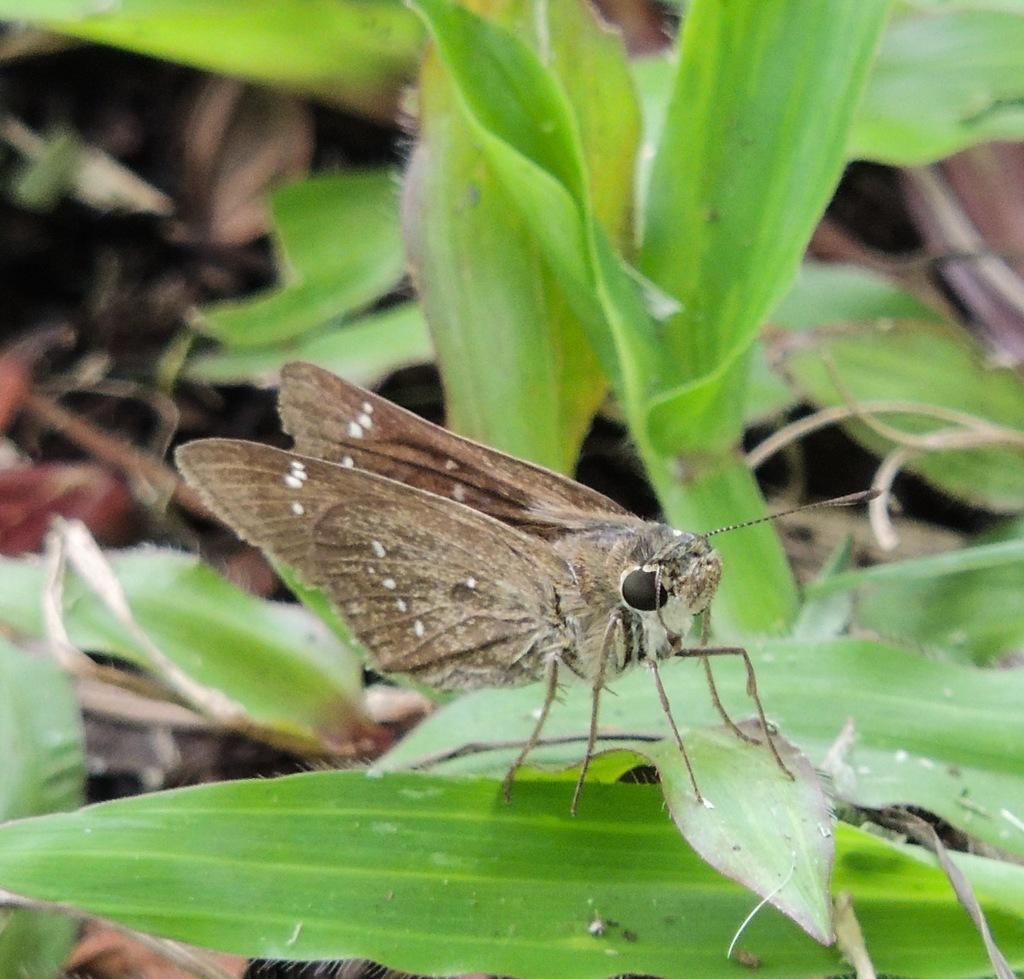What type of creature can be seen on the leaves in the image? There is an insect on the leaves in the image. What is visible in the background of the image? The background of the image includes green leaves. Can you see any beds or lakes in the image? No, there are no beds or lakes present in the image. How many insects are walking on the leaves in the image? The image only shows one insect on the leaves, and there is no indication that it is walking. 